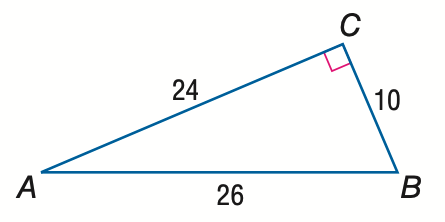Answer the mathemtical geometry problem and directly provide the correct option letter.
Question: Express the ratio of \tan B as a decimal to the nearest hundredth.
Choices: A: 0.38 B: 0.42 C: 0.92 D: 2.40 D 